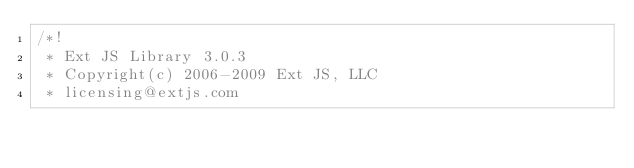<code> <loc_0><loc_0><loc_500><loc_500><_JavaScript_>/*!
 * Ext JS Library 3.0.3
 * Copyright(c) 2006-2009 Ext JS, LLC
 * licensing@extjs.com</code> 